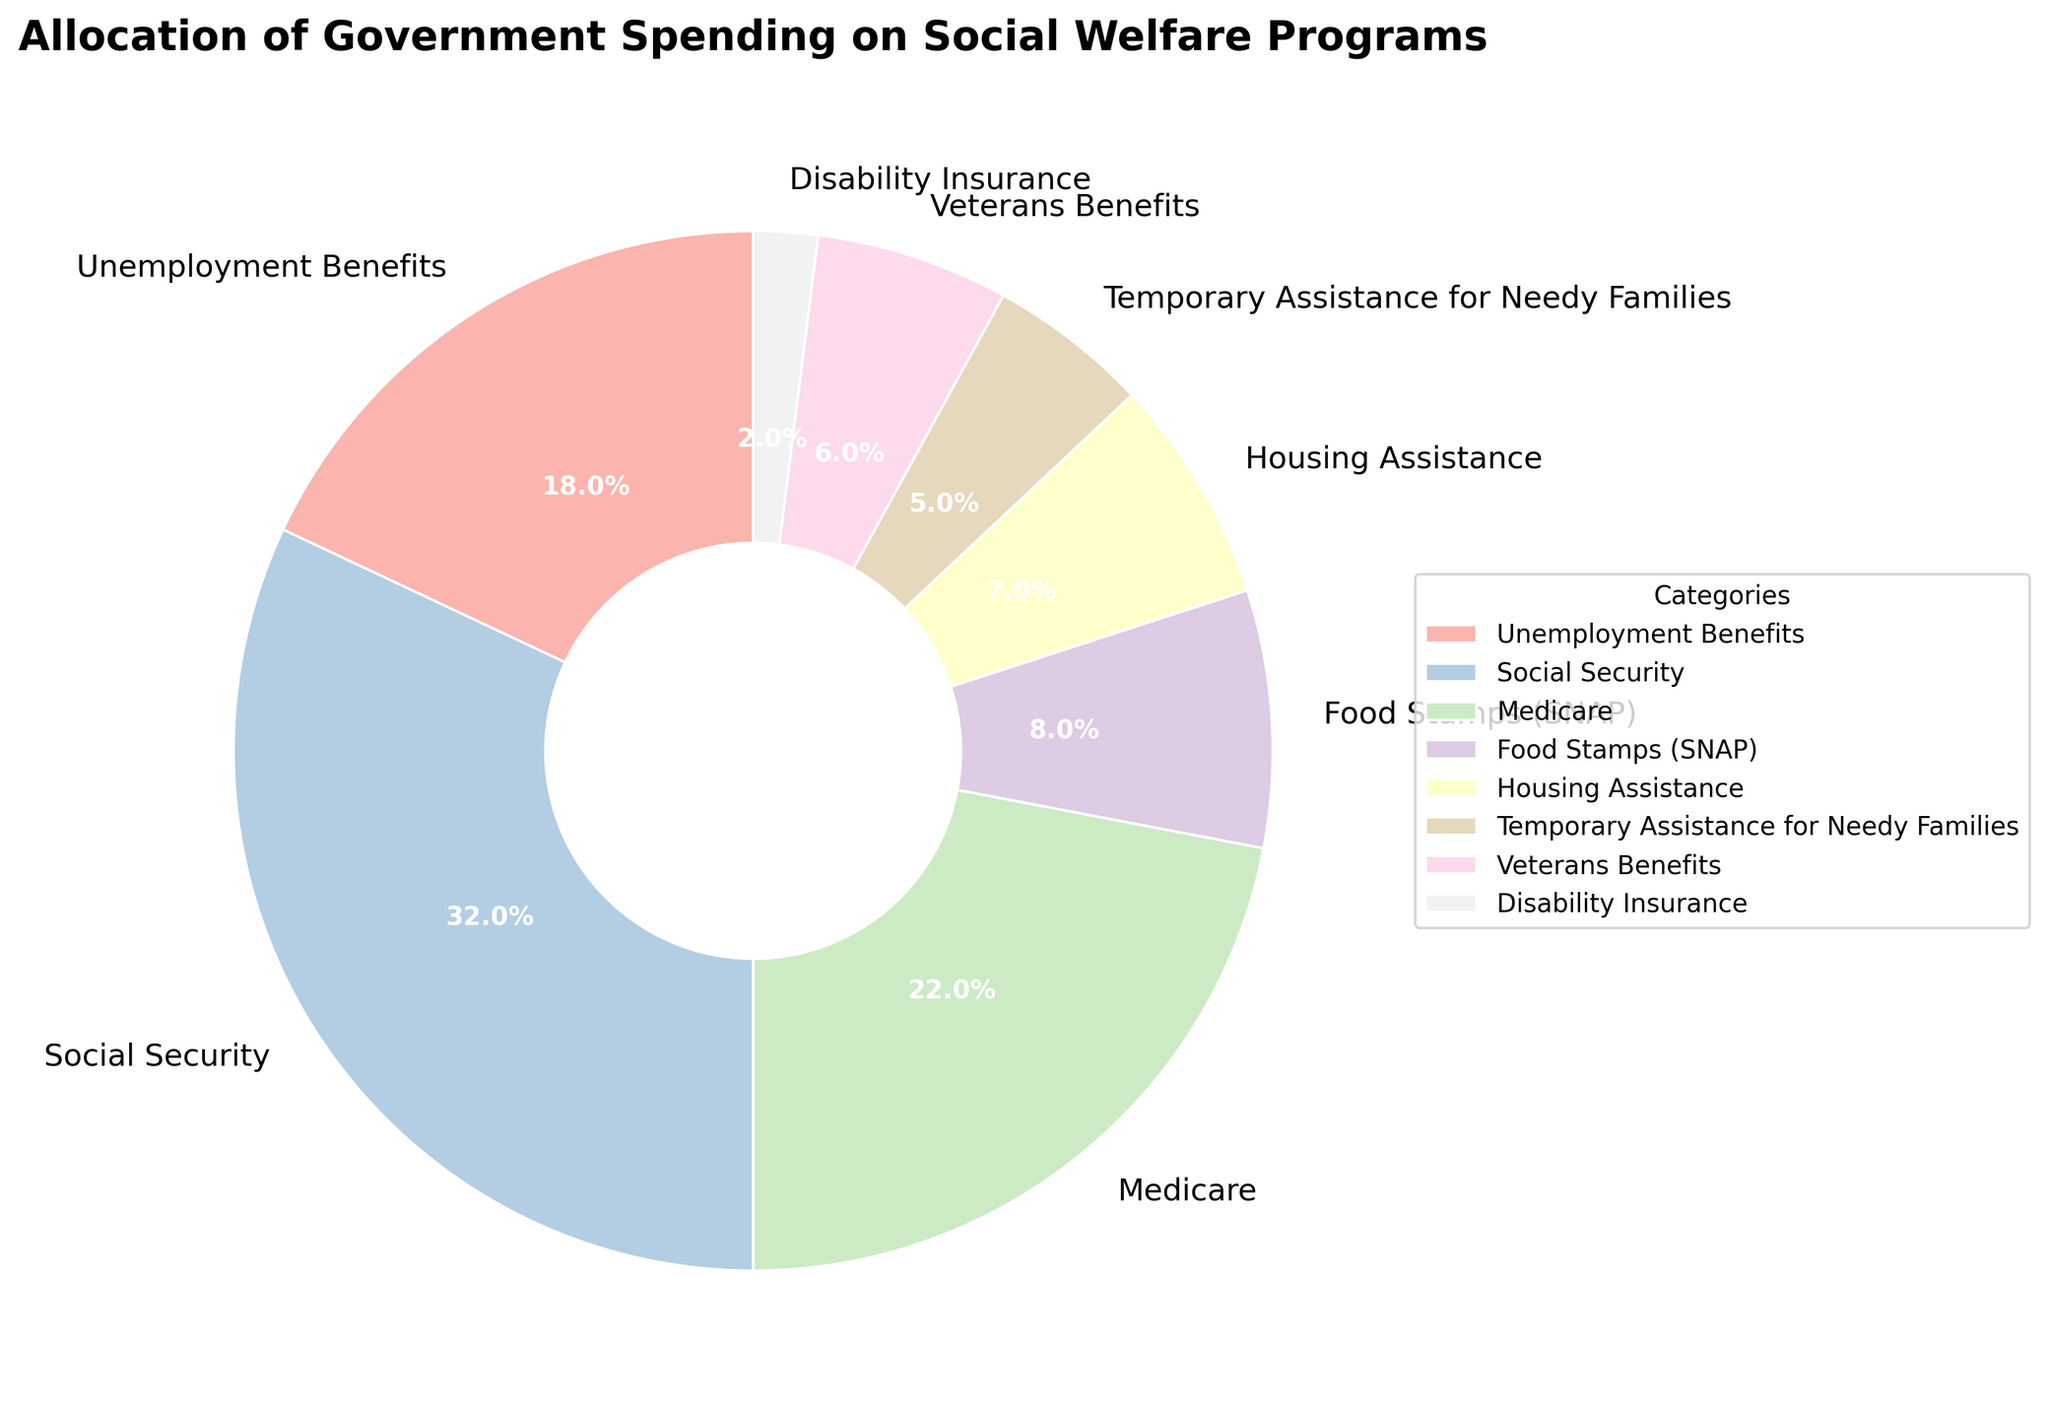What's the largest category of government spending on social welfare programs? By observing the pie chart, the segment representing Social Security is the largest among all categories.
Answer: Social Security Which category receives more funds: Medicare or Unemployment Benefits? By comparing the size of the pie chart segments, Medicare (22%) is larger than Unemployment Benefits (18%).
Answer: Medicare What is the combined percentage of spending on Veterans Benefits and Disability Insurance? Adding the percentages of Veterans Benefits (6%) and Disability Insurance (2%) leads to 6% + 2% = 8%.
Answer: 8% Which categories together make up more than half of the government's social welfare spending? Social Security (32%), Medicare (22%), and Unemployment Benefits (18%) together make 32% + 22% + 18% = 72%, which is more than 50%.
Answer: Social Security, Medicare, Unemployment Benefits If spending on Housing Assistance increased to 10%, what would be the impact on the total percentage? Currently, Housing Assistance is 7%. The increase to 10% would add 3% more, raising the overall total percentage to more than 100% if we don't adjust other categories.
Answer: It would exceed 100% Does Food Stamps (SNAP) receive more funding than Temporary Assistance for Needy Families (TANF) and Disability Insurance combined? Food Stamps (SNAP) gets 8%, while Temporary Assistance for Needy Families and Disability Insurance together constitute 5% + 2% = 7%. Thus, 8% is larger than 7%.
Answer: Yes Which category has the least amount of spending? The pie chart indicates that Disability Insurance, with 2%, has the smallest segment.
Answer: Disability Insurance What is the percentage difference between the highest and lowest funded categories? The highest is Social Security at 32%, and the lowest is Disability Insurance at 2%. The difference is 32% - 2% = 30%.
Answer: 30% What fraction of the total spending is allocated to Medicare and Social Security combined? Medicare is 22%, and Social Security is 32%. Combined, this is 22% + 32% = 54%. As a fraction of the total 100%, it is 54/100 or 27/50.
Answer: 27/50 